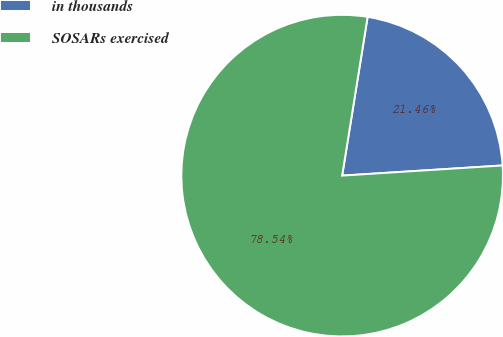Convert chart. <chart><loc_0><loc_0><loc_500><loc_500><pie_chart><fcel>in thousands<fcel>SOSARs exercised<nl><fcel>21.46%<fcel>78.54%<nl></chart> 